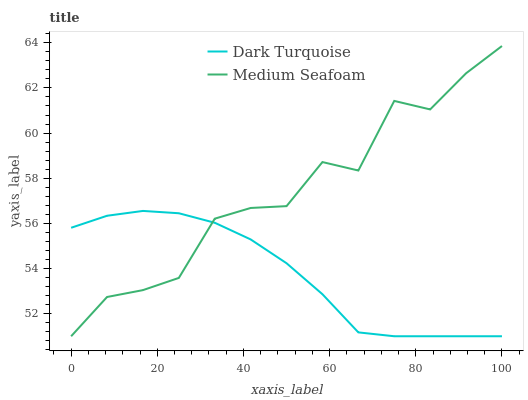Does Dark Turquoise have the minimum area under the curve?
Answer yes or no. Yes. Does Medium Seafoam have the maximum area under the curve?
Answer yes or no. Yes. Does Medium Seafoam have the minimum area under the curve?
Answer yes or no. No. Is Dark Turquoise the smoothest?
Answer yes or no. Yes. Is Medium Seafoam the roughest?
Answer yes or no. Yes. Is Medium Seafoam the smoothest?
Answer yes or no. No. Does Dark Turquoise have the lowest value?
Answer yes or no. Yes. Does Medium Seafoam have the highest value?
Answer yes or no. Yes. Does Medium Seafoam intersect Dark Turquoise?
Answer yes or no. Yes. Is Medium Seafoam less than Dark Turquoise?
Answer yes or no. No. Is Medium Seafoam greater than Dark Turquoise?
Answer yes or no. No. 